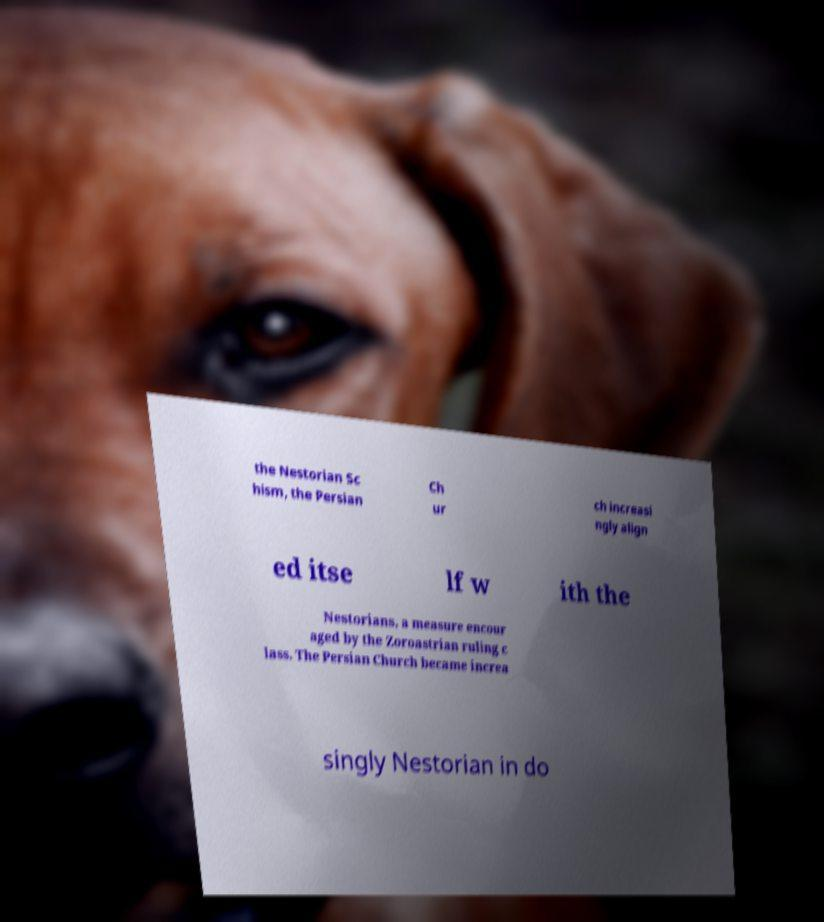For documentation purposes, I need the text within this image transcribed. Could you provide that? the Nestorian Sc hism, the Persian Ch ur ch increasi ngly align ed itse lf w ith the Nestorians, a measure encour aged by the Zoroastrian ruling c lass. The Persian Church became increa singly Nestorian in do 